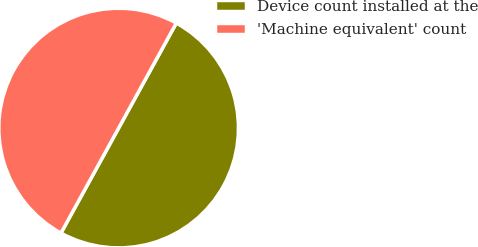Convert chart. <chart><loc_0><loc_0><loc_500><loc_500><pie_chart><fcel>Device count installed at the<fcel>'Machine equivalent' count<nl><fcel>50.0%<fcel>50.0%<nl></chart> 